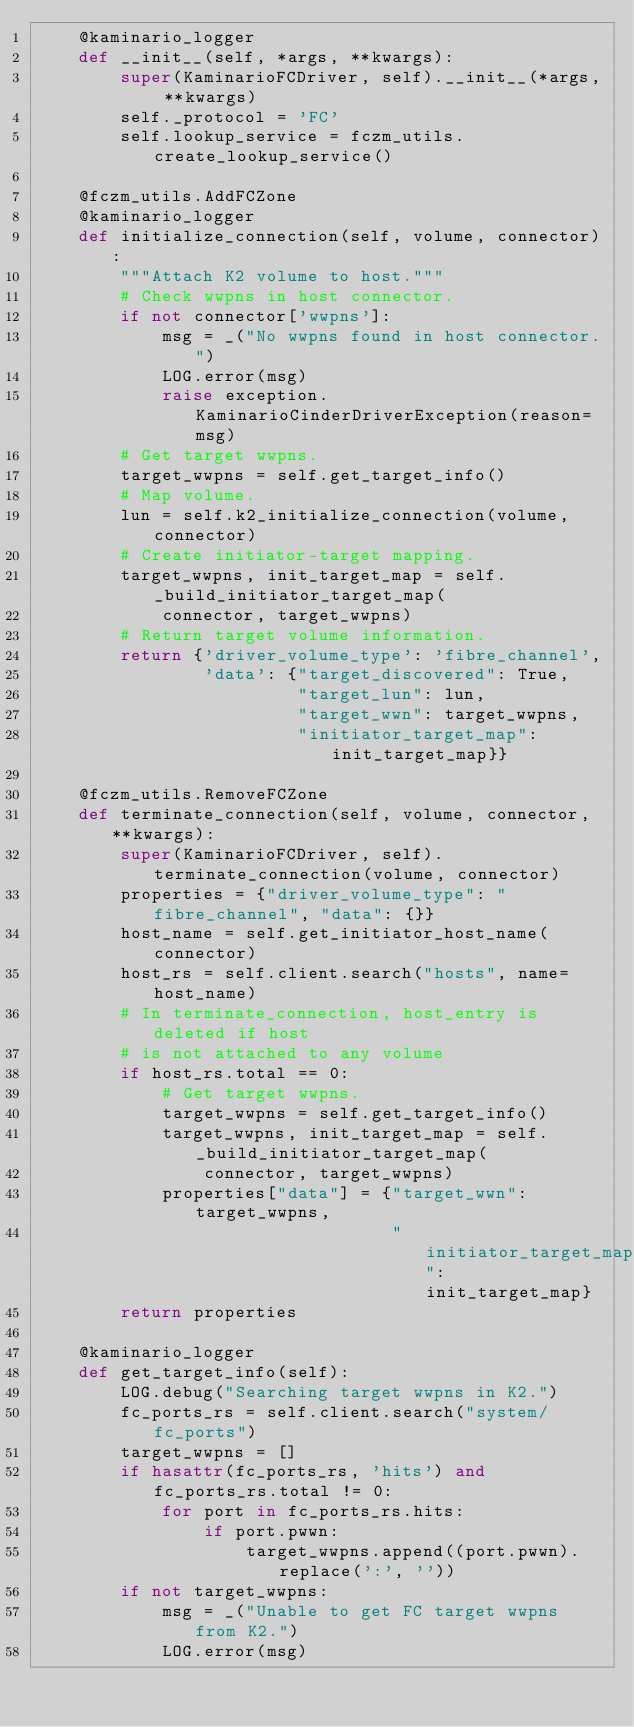Convert code to text. <code><loc_0><loc_0><loc_500><loc_500><_Python_>    @kaminario_logger
    def __init__(self, *args, **kwargs):
        super(KaminarioFCDriver, self).__init__(*args, **kwargs)
        self._protocol = 'FC'
        self.lookup_service = fczm_utils.create_lookup_service()

    @fczm_utils.AddFCZone
    @kaminario_logger
    def initialize_connection(self, volume, connector):
        """Attach K2 volume to host."""
        # Check wwpns in host connector.
        if not connector['wwpns']:
            msg = _("No wwpns found in host connector.")
            LOG.error(msg)
            raise exception.KaminarioCinderDriverException(reason=msg)
        # Get target wwpns.
        target_wwpns = self.get_target_info()
        # Map volume.
        lun = self.k2_initialize_connection(volume, connector)
        # Create initiator-target mapping.
        target_wwpns, init_target_map = self._build_initiator_target_map(
            connector, target_wwpns)
        # Return target volume information.
        return {'driver_volume_type': 'fibre_channel',
                'data': {"target_discovered": True,
                         "target_lun": lun,
                         "target_wwn": target_wwpns,
                         "initiator_target_map": init_target_map}}

    @fczm_utils.RemoveFCZone
    def terminate_connection(self, volume, connector, **kwargs):
        super(KaminarioFCDriver, self).terminate_connection(volume, connector)
        properties = {"driver_volume_type": "fibre_channel", "data": {}}
        host_name = self.get_initiator_host_name(connector)
        host_rs = self.client.search("hosts", name=host_name)
        # In terminate_connection, host_entry is deleted if host
        # is not attached to any volume
        if host_rs.total == 0:
            # Get target wwpns.
            target_wwpns = self.get_target_info()
            target_wwpns, init_target_map = self._build_initiator_target_map(
                connector, target_wwpns)
            properties["data"] = {"target_wwn": target_wwpns,
                                  "initiator_target_map": init_target_map}
        return properties

    @kaminario_logger
    def get_target_info(self):
        LOG.debug("Searching target wwpns in K2.")
        fc_ports_rs = self.client.search("system/fc_ports")
        target_wwpns = []
        if hasattr(fc_ports_rs, 'hits') and fc_ports_rs.total != 0:
            for port in fc_ports_rs.hits:
                if port.pwwn:
                    target_wwpns.append((port.pwwn).replace(':', ''))
        if not target_wwpns:
            msg = _("Unable to get FC target wwpns from K2.")
            LOG.error(msg)</code> 